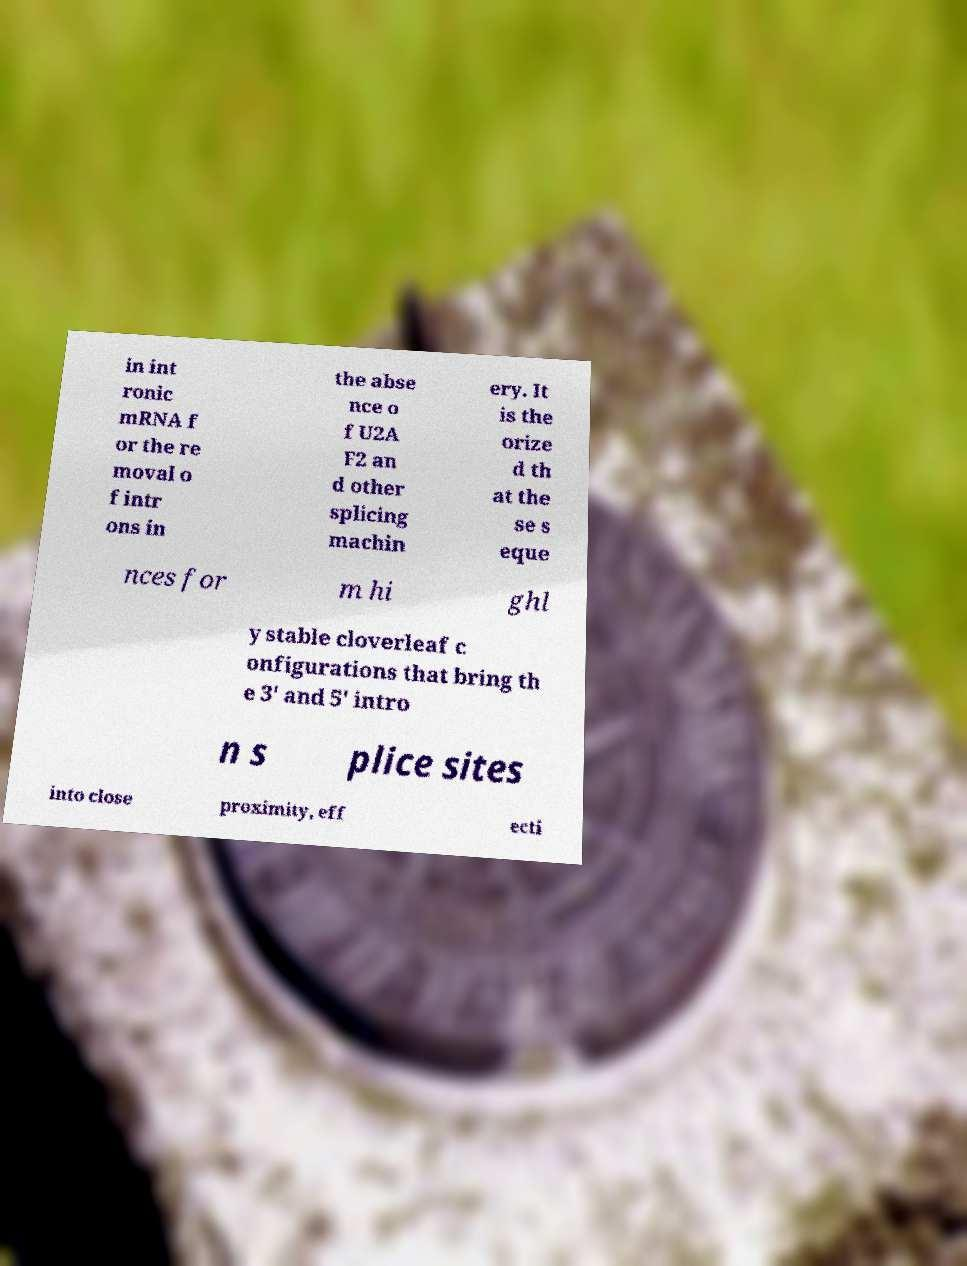Can you read and provide the text displayed in the image?This photo seems to have some interesting text. Can you extract and type it out for me? in int ronic mRNA f or the re moval o f intr ons in the abse nce o f U2A F2 an d other splicing machin ery. It is the orize d th at the se s eque nces for m hi ghl y stable cloverleaf c onfigurations that bring th e 3' and 5' intro n s plice sites into close proximity, eff ecti 